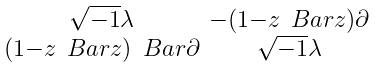<formula> <loc_0><loc_0><loc_500><loc_500>\begin{smallmatrix} \sqrt { - 1 } \lambda & - ( 1 - z \ B a r { z } ) \partial \\ ( 1 - z \ B a r { z } ) \ B a r { \partial } & \sqrt { - 1 } \lambda \end{smallmatrix}</formula> 